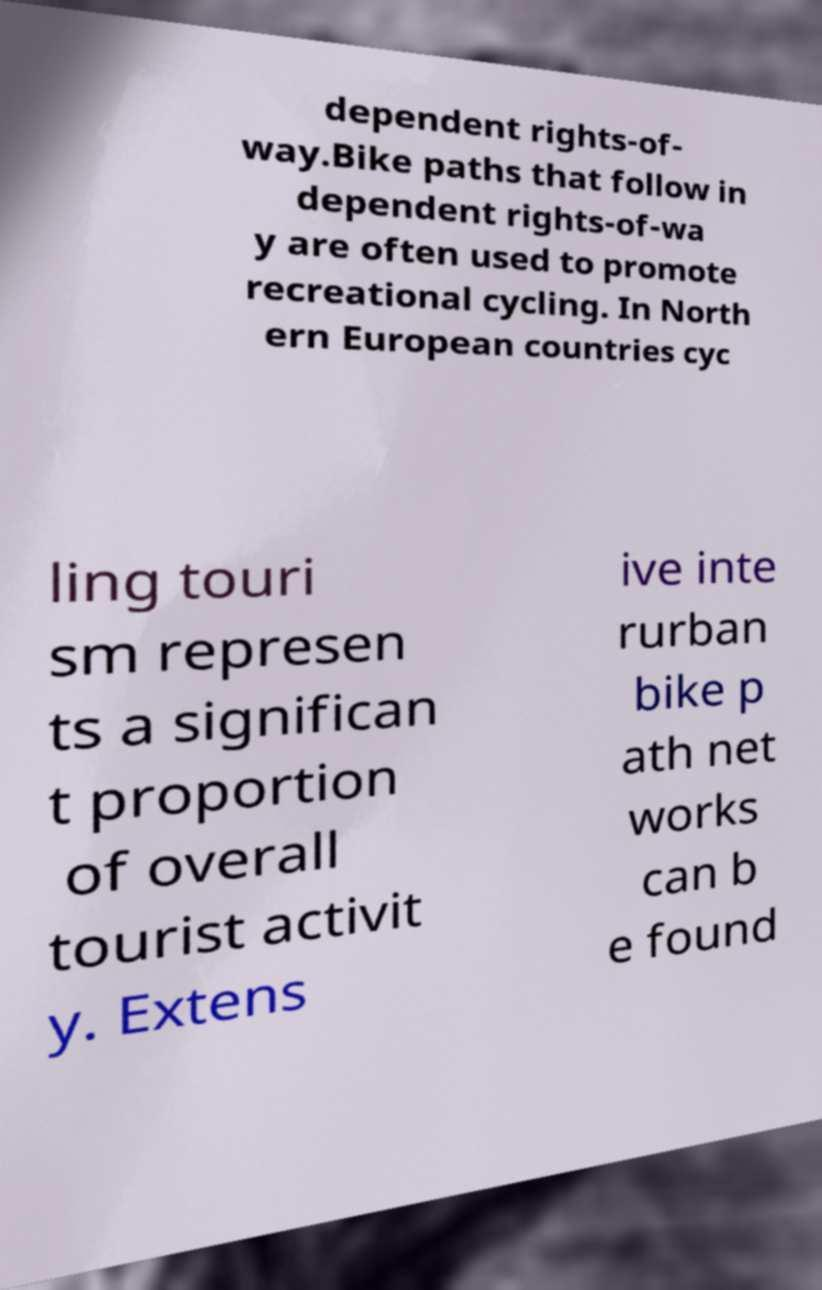What messages or text are displayed in this image? I need them in a readable, typed format. dependent rights-of- way.Bike paths that follow in dependent rights-of-wa y are often used to promote recreational cycling. In North ern European countries cyc ling touri sm represen ts a significan t proportion of overall tourist activit y. Extens ive inte rurban bike p ath net works can b e found 